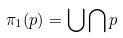<formula> <loc_0><loc_0><loc_500><loc_500>\pi _ { 1 } ( p ) = \bigcup \bigcap p</formula> 